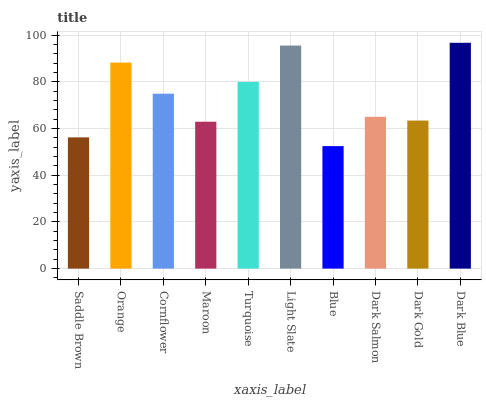Is Blue the minimum?
Answer yes or no. Yes. Is Dark Blue the maximum?
Answer yes or no. Yes. Is Orange the minimum?
Answer yes or no. No. Is Orange the maximum?
Answer yes or no. No. Is Orange greater than Saddle Brown?
Answer yes or no. Yes. Is Saddle Brown less than Orange?
Answer yes or no. Yes. Is Saddle Brown greater than Orange?
Answer yes or no. No. Is Orange less than Saddle Brown?
Answer yes or no. No. Is Cornflower the high median?
Answer yes or no. Yes. Is Dark Salmon the low median?
Answer yes or no. Yes. Is Dark Salmon the high median?
Answer yes or no. No. Is Turquoise the low median?
Answer yes or no. No. 